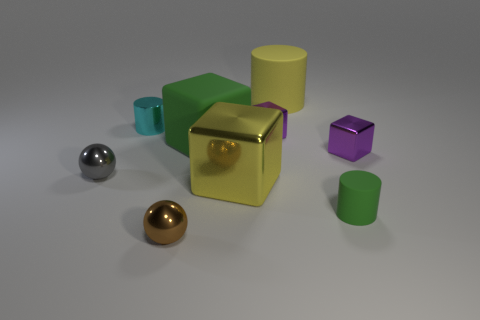Subtract all shiny blocks. How many blocks are left? 1 Add 1 yellow rubber things. How many objects exist? 10 Subtract all yellow cubes. How many cubes are left? 3 Subtract all spheres. How many objects are left? 7 Subtract all green cubes. Subtract all gray balls. How many cubes are left? 3 Subtract all cyan spheres. How many brown blocks are left? 0 Subtract all tiny rubber cylinders. Subtract all tiny matte cylinders. How many objects are left? 7 Add 3 big yellow shiny blocks. How many big yellow shiny blocks are left? 4 Add 2 metallic blocks. How many metallic blocks exist? 5 Subtract 0 blue cubes. How many objects are left? 9 